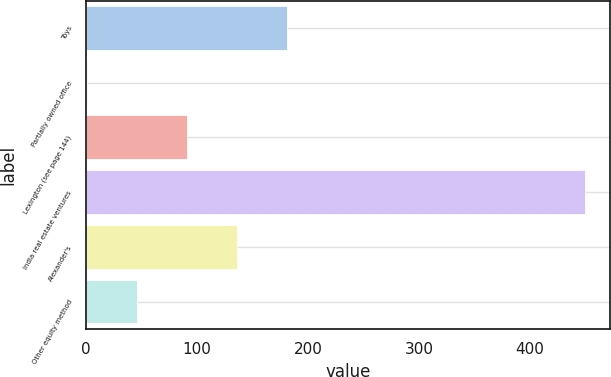Convert chart. <chart><loc_0><loc_0><loc_500><loc_500><bar_chart><fcel>Toys<fcel>Partially owned office<fcel>Lexington (see page 144)<fcel>India real estate ventures<fcel>Alexander's<fcel>Other equity method<nl><fcel>180.6<fcel>1<fcel>90.8<fcel>450<fcel>135.7<fcel>45.9<nl></chart> 